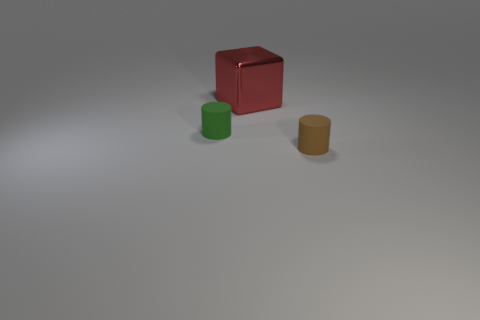Are there any other things that are made of the same material as the red cube?
Your response must be concise. No. What material is the object that is behind the tiny rubber thing to the left of the small cylinder that is on the right side of the big shiny cube made of?
Give a very brief answer. Metal. There is a thing that is made of the same material as the brown cylinder; what shape is it?
Offer a terse response. Cylinder. There is a tiny cylinder on the left side of the shiny thing; are there any large blocks to the left of it?
Keep it short and to the point. No. The red cube has what size?
Offer a very short reply. Large. What number of things are large metal things or purple matte cylinders?
Ensure brevity in your answer.  1. Does the tiny cylinder to the right of the small green thing have the same material as the tiny cylinder left of the big shiny object?
Provide a short and direct response. Yes. What is the color of the other cylinder that is made of the same material as the brown cylinder?
Provide a succinct answer. Green. What number of green rubber cylinders are the same size as the green object?
Offer a terse response. 0. How many other objects are the same color as the metallic object?
Keep it short and to the point. 0. 